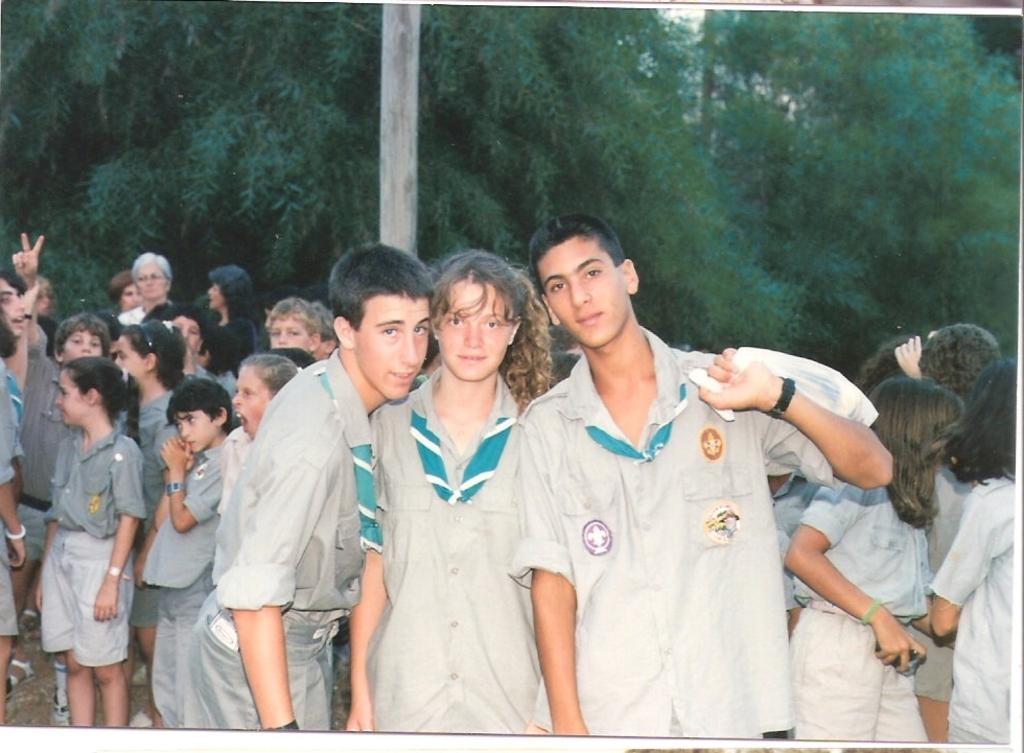Where was the image taken? The image was taken outside. What can be seen in the background of the image? There are trees visible at the top of the image. How many people are in the image? There are multiple people in the image. Where are the people located in the image? The people are standing in the middle of the image. What are the people wearing in the image? All the people are wearing the same dress. What time is displayed on the clock in the image? There is no clock present in the image. What type of war is depicted in the image? There is no war depicted in the image; it features multiple people wearing the same dress outside with trees in the background. 